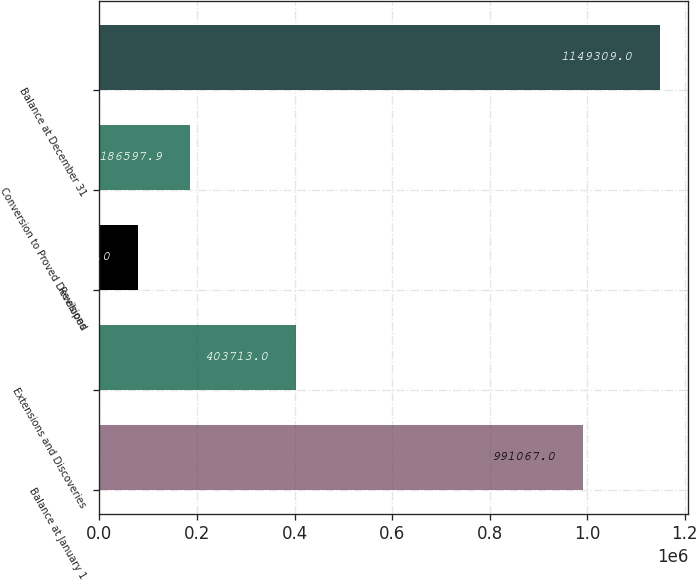Convert chart. <chart><loc_0><loc_0><loc_500><loc_500><bar_chart><fcel>Balance at January 1<fcel>Extensions and Discoveries<fcel>Revisions<fcel>Conversion to Proved Developed<fcel>Balance at December 31<nl><fcel>991067<fcel>403713<fcel>79630<fcel>186598<fcel>1.14931e+06<nl></chart> 